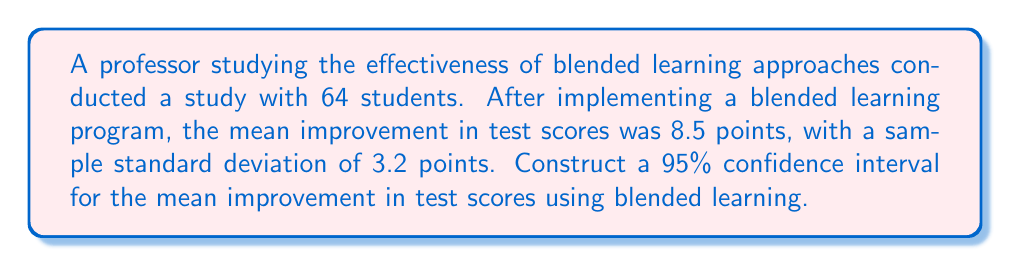Help me with this question. To construct a 95% confidence interval for the mean improvement in test scores, we'll use the formula:

$$\text{CI} = \bar{x} \pm t_{\alpha/2} \cdot \frac{s}{\sqrt{n}}$$

Where:
$\bar{x}$ = sample mean
$t_{\alpha/2}$ = t-value for 95% confidence level with (n-1) degrees of freedom
$s$ = sample standard deviation
$n$ = sample size

Step 1: Identify the known values
$\bar{x} = 8.5$
$s = 3.2$
$n = 64$
Confidence level = 95% (α = 0.05)

Step 2: Find the t-value
Degrees of freedom = n - 1 = 64 - 1 = 63
For a 95% confidence interval with 63 degrees of freedom, $t_{\alpha/2} = 1.998$ (from t-distribution table)

Step 3: Calculate the margin of error
$$\text{Margin of Error} = t_{\alpha/2} \cdot \frac{s}{\sqrt{n}} = 1.998 \cdot \frac{3.2}{\sqrt{64}} = 0.798$$

Step 4: Calculate the confidence interval
Lower bound: $8.5 - 0.798 = 7.702$
Upper bound: $8.5 + 0.798 = 9.298$

Therefore, the 95% confidence interval for the mean improvement in test scores is (7.702, 9.298).
Answer: (7.702, 9.298) 